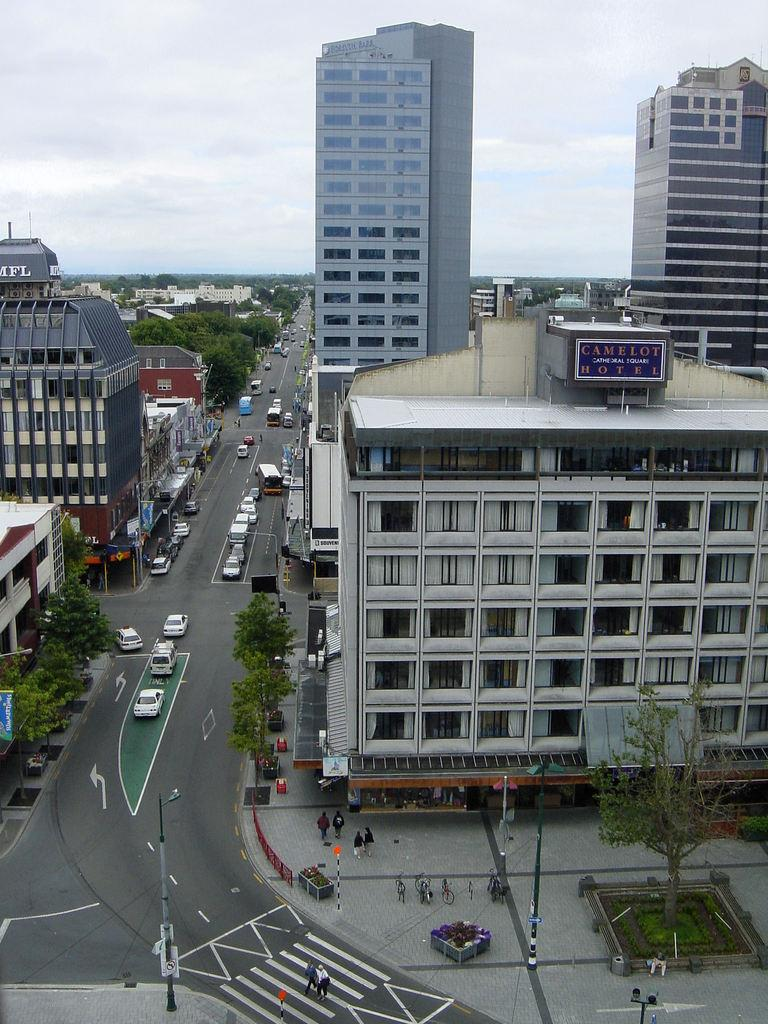What type of structures are located on the right side of the image? There are skyscrapers on the right side of the image. What type of vehicles can be seen in the image? There are cars in the image. What type of structures are located on the left side of the image? There are buildings on the left side of the image. Can you see a knife cutting an orange in the image? There is no knife or orange present in the image. Is there any thread visible in the image? There is no thread visible in the image. 